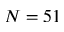Convert formula to latex. <formula><loc_0><loc_0><loc_500><loc_500>N = 5 1</formula> 